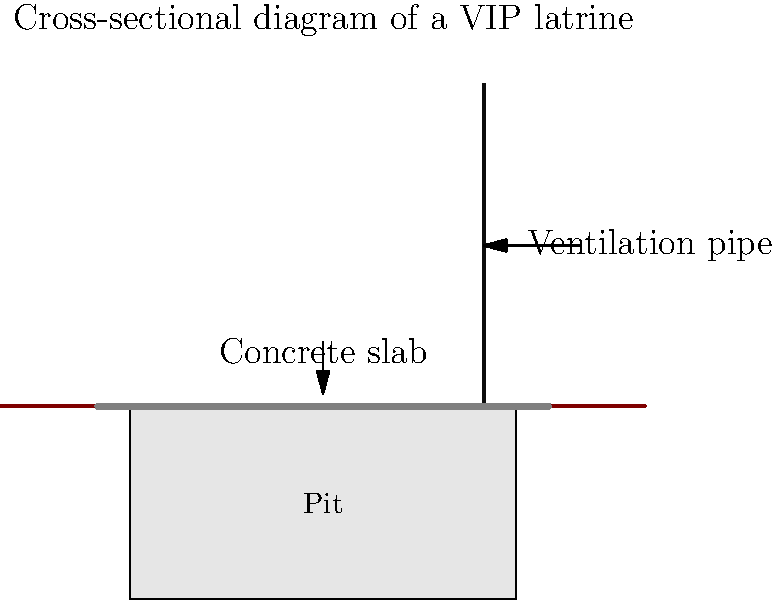In the context of sustainable sanitation systems for developing areas, what is the primary purpose of the ventilation pipe in a Ventilated Improved Pit (VIP) latrine, as shown in the cross-sectional diagram? To understand the purpose of the ventilation pipe in a VIP latrine, let's break down its functions:

1. Odor control: The ventilation pipe creates a draft that pulls air from the squat hole or seat through the pit and up the pipe. This flow of air helps to minimize odors in the latrine superstructure.

2. Fly control: The pipe is typically fitted with a fly screen at the top. Flies are attracted to light and will try to exit through the pipe rather than the squat hole. The screen prevents flies from entering or exiting the pit, effectively trapping them.

3. Moisture reduction: The airflow created by the ventilation pipe helps to dry out the contents of the pit, which can slow down the rate at which the pit fills and reduce pathogen survival.

4. Methane dispersion: As waste decomposes, it produces methane gas. The ventilation pipe helps to safely disperse this gas into the atmosphere, reducing the risk of explosion or asphyxiation.

5. Improved user experience: By reducing odors and flies, the ventilation pipe makes the latrine more pleasant to use, encouraging consistent use and improving overall sanitation practices.

In the context of HIV/AIDS prevention, improved sanitation systems like VIP latrines are crucial because:

a) They reduce the spread of opportunistic infections that can be particularly dangerous for immunocompromised individuals.
b) Better sanitation facilities encourage consistent use, reducing open defecation and the associated health risks.
c) Improved sanitation contributes to overall community health, which is essential for comprehensive HIV/AIDS management strategies.
Answer: Odor and fly control, while improving overall sanitation and user experience. 